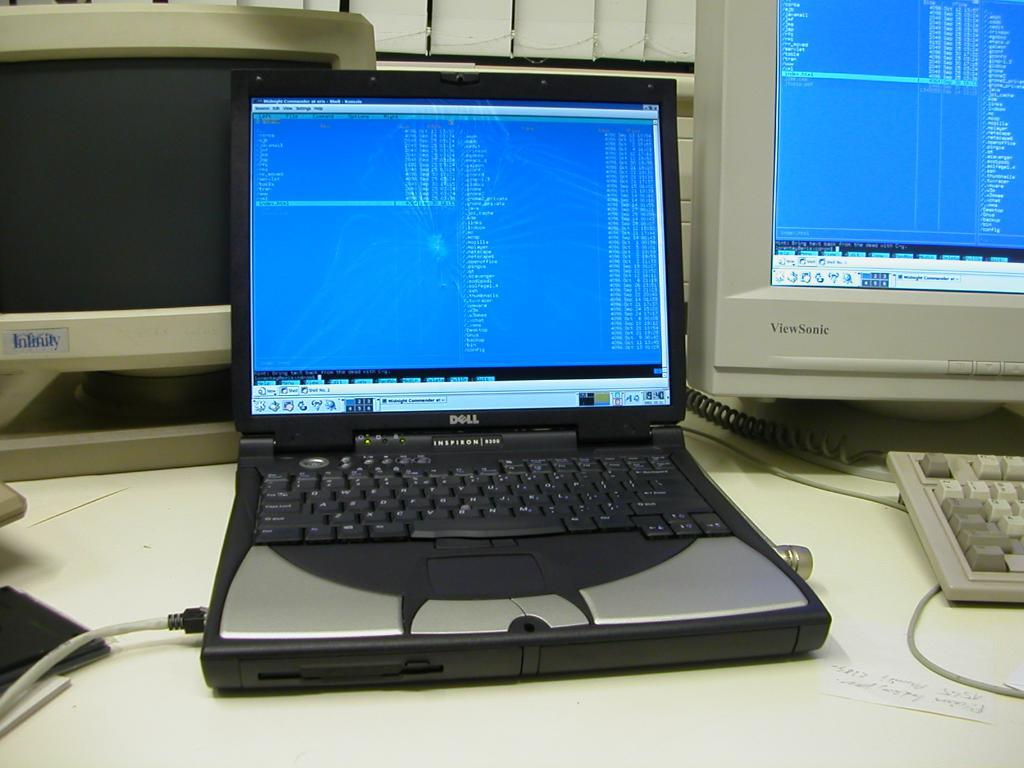<image>
Relay a brief, clear account of the picture shown. the word file is on the front of the computer 